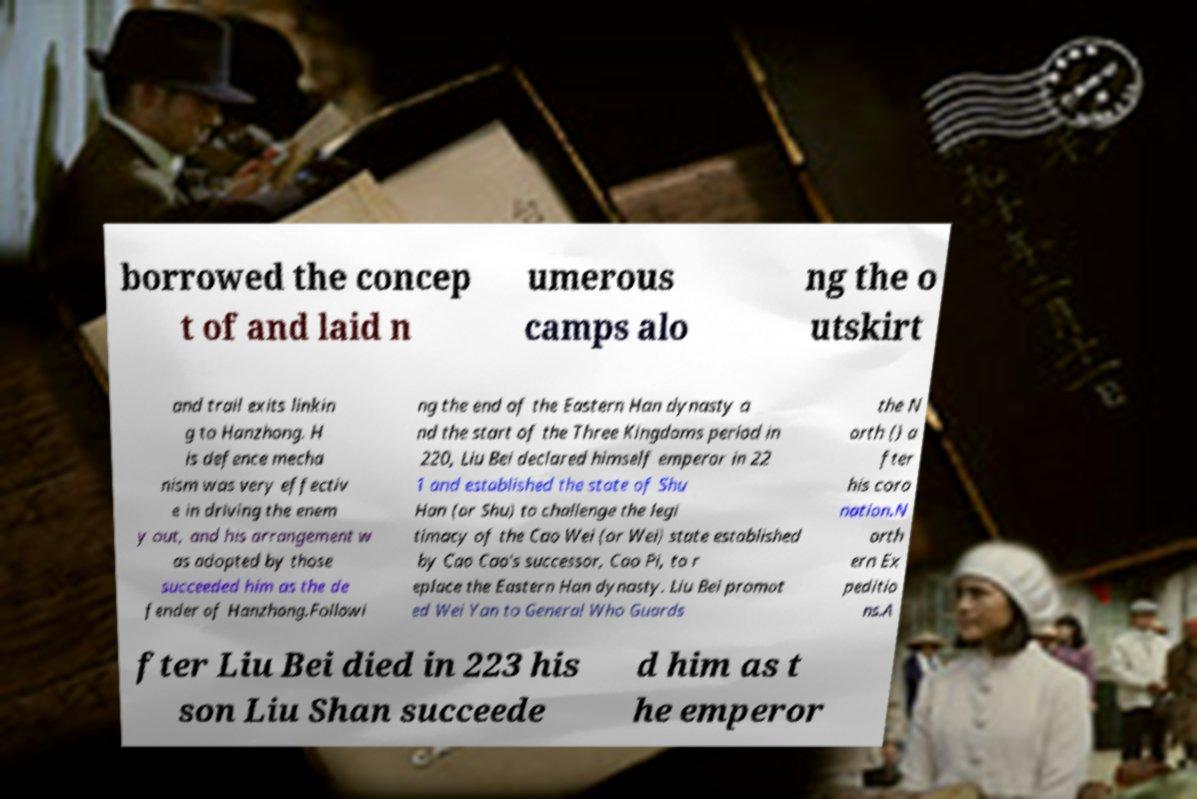Can you read and provide the text displayed in the image?This photo seems to have some interesting text. Can you extract and type it out for me? borrowed the concep t of and laid n umerous camps alo ng the o utskirt and trail exits linkin g to Hanzhong. H is defence mecha nism was very effectiv e in driving the enem y out, and his arrangement w as adopted by those succeeded him as the de fender of Hanzhong.Followi ng the end of the Eastern Han dynasty a nd the start of the Three Kingdoms period in 220, Liu Bei declared himself emperor in 22 1 and established the state of Shu Han (or Shu) to challenge the legi timacy of the Cao Wei (or Wei) state established by Cao Cao's successor, Cao Pi, to r eplace the Eastern Han dynasty. Liu Bei promot ed Wei Yan to General Who Guards the N orth () a fter his coro nation.N orth ern Ex peditio ns.A fter Liu Bei died in 223 his son Liu Shan succeede d him as t he emperor 